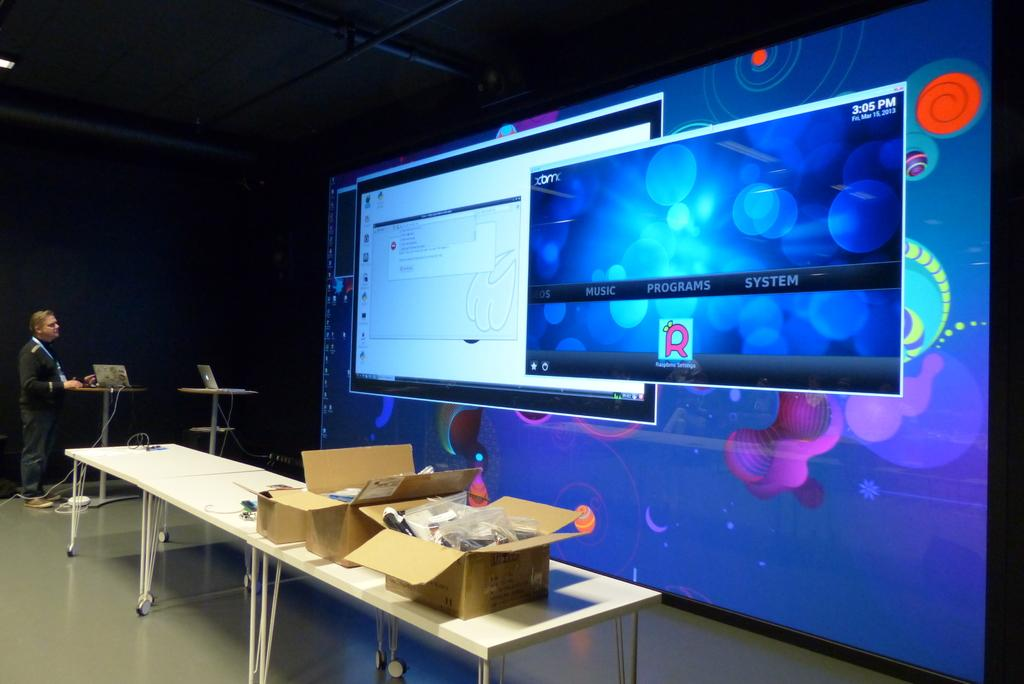<image>
Present a compact description of the photo's key features. A screen shows a few different computer windows, including one that says the time is 3:05 PM. 